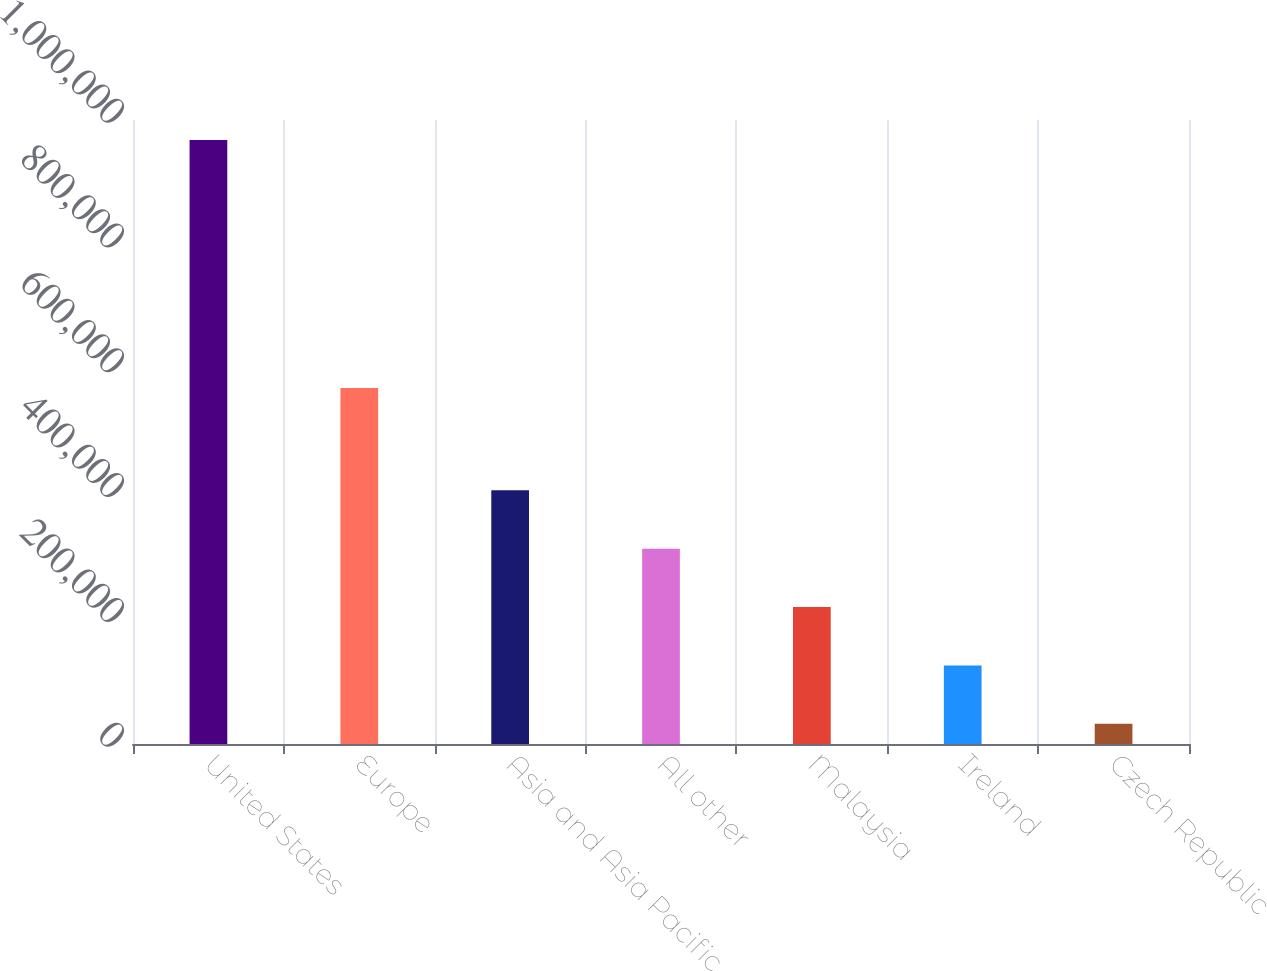Convert chart to OTSL. <chart><loc_0><loc_0><loc_500><loc_500><bar_chart><fcel>United States<fcel>Europe<fcel>Asia and Asia Pacific<fcel>All other<fcel>Malaysia<fcel>Ireland<fcel>Czech Republic<nl><fcel>967819<fcel>570672<fcel>406511<fcel>312959<fcel>219408<fcel>125856<fcel>32305<nl></chart> 